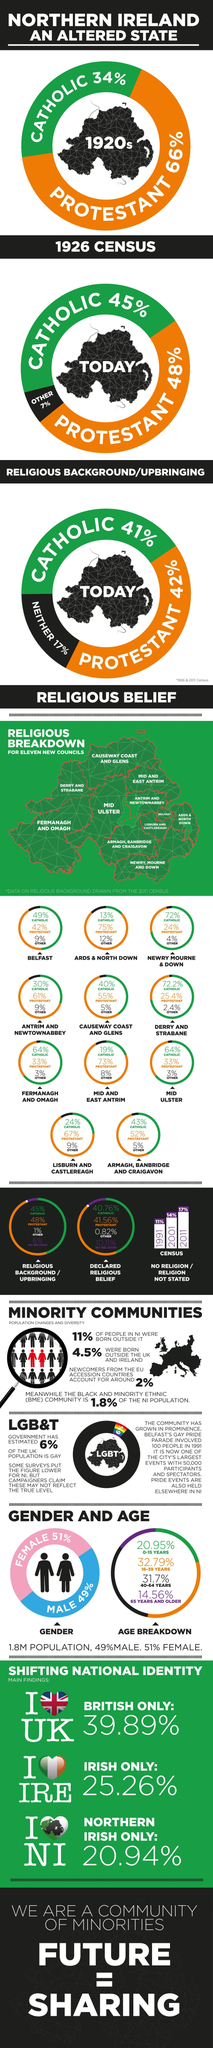What percentage of population of Mid Ulster are Protestants?
Answer the question with a short phrase. 33% How many protestants are there in ARDS & NORTH DOWN? 75% What is the color code given to Catholics- red, green, orange, white? green How many Christian Catholics are there in Newry Mourne & Down? 72% To which age group highest population of Northern Ireland belongs? 16-39 years Which is the largest form of Christianity in Northern Ireland? Protestant What percentage of people in Ireland love their home country? 25.26% Which form of Christianity has second majority in Belfast? Protestant What percentage of Britain love their home country? 39.89% Which is the left most state of Northern Island? Fermanagh and Omagh 